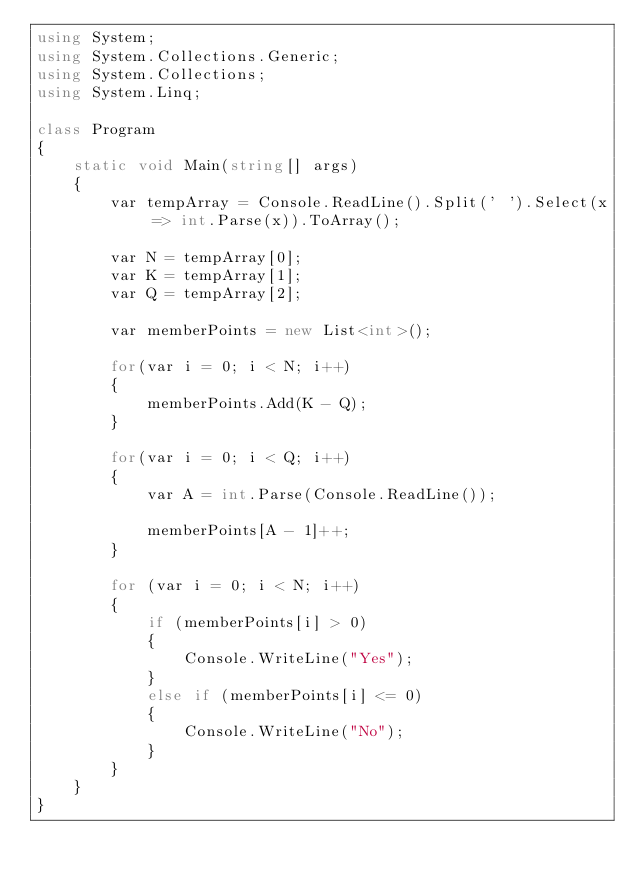Convert code to text. <code><loc_0><loc_0><loc_500><loc_500><_C#_>using System;
using System.Collections.Generic;
using System.Collections;
using System.Linq;

class Program
{
    static void Main(string[] args)
    {
        var tempArray = Console.ReadLine().Split(' ').Select(x => int.Parse(x)).ToArray();

        var N = tempArray[0];
        var K = tempArray[1];
        var Q = tempArray[2];

        var memberPoints = new List<int>();

        for(var i = 0; i < N; i++)
        {
            memberPoints.Add(K - Q);
        }

        for(var i = 0; i < Q; i++)
        {
            var A = int.Parse(Console.ReadLine());

            memberPoints[A - 1]++;
        }

        for (var i = 0; i < N; i++)
        {
            if (memberPoints[i] > 0)
            {
                Console.WriteLine("Yes");
            }
            else if (memberPoints[i] <= 0)
            {
                Console.WriteLine("No");
            }
        }
    }
}</code> 